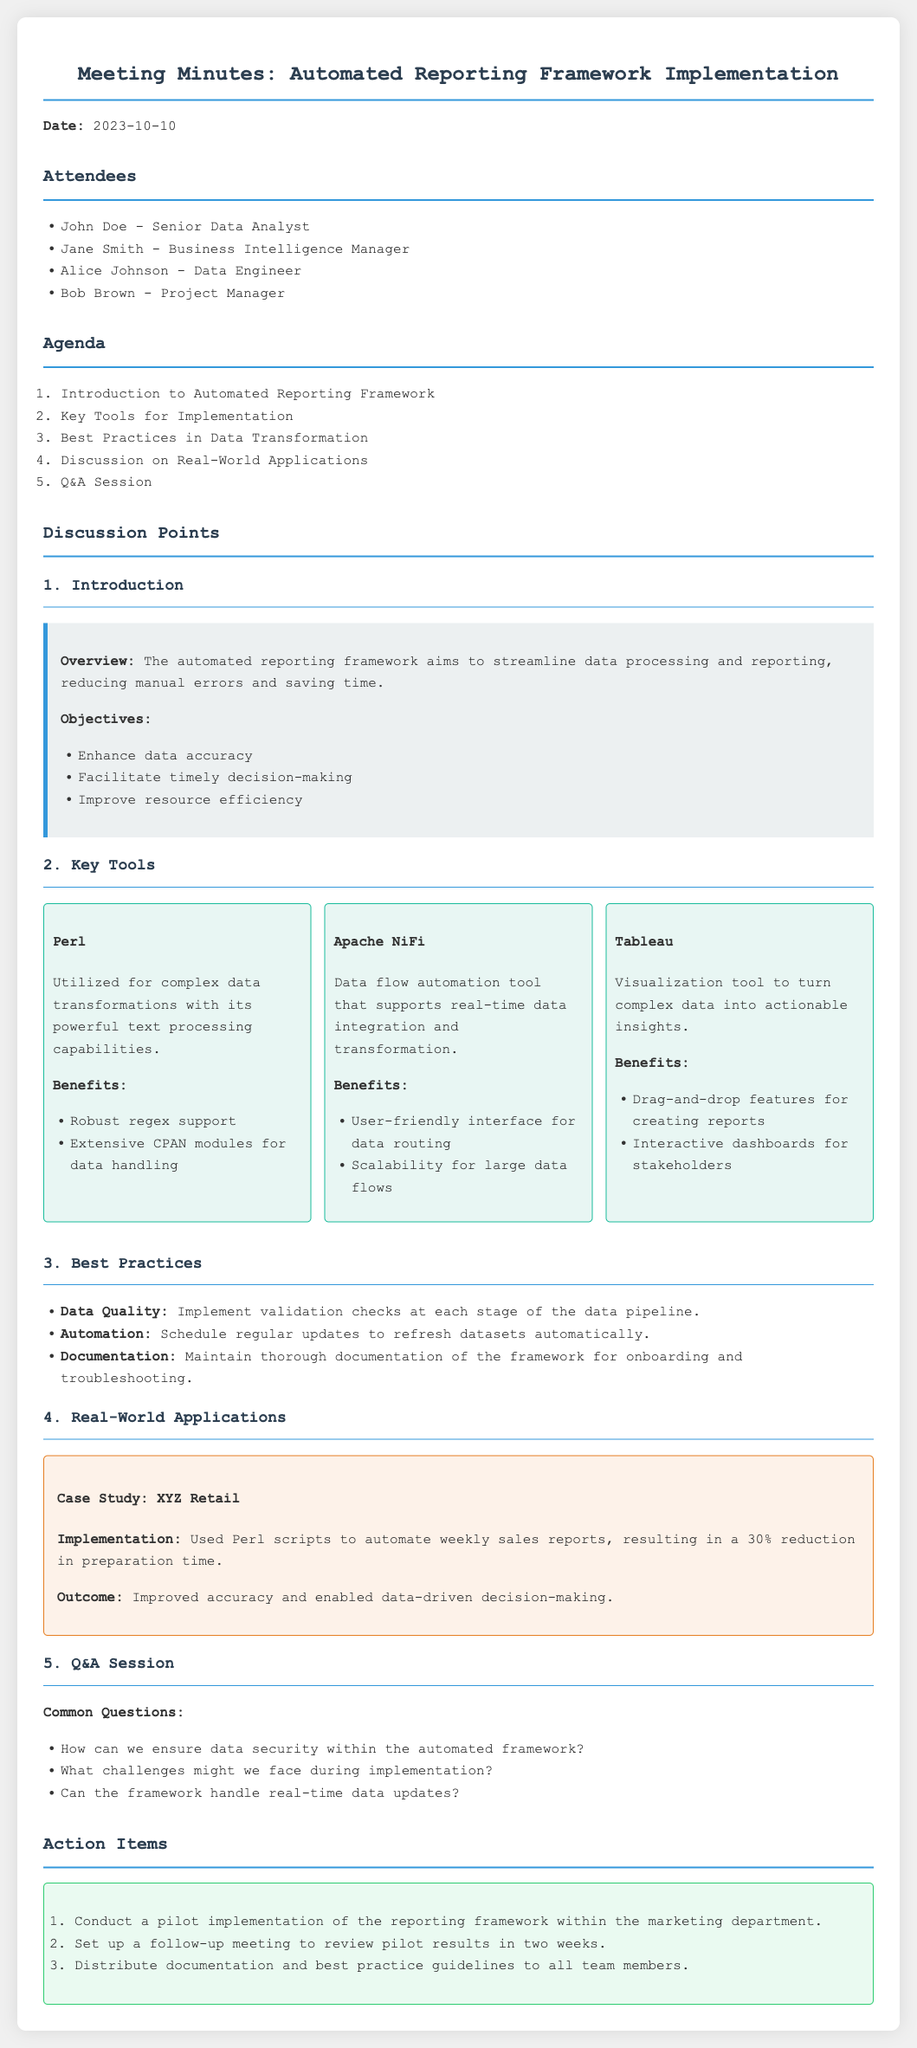What is the date of the meeting? The document states the meeting date clearly at the beginning.
Answer: 2023-10-10 Who is the Business Intelligence Manager? The list of attendees includes all participants and their roles.
Answer: Jane Smith What tool is used for complex data transformations? This tool is specifically mentioned in the section about key tools for implementation.
Answer: Perl What is one objective of the automated reporting framework? Objectives are listed in the overview section, highlighting the goals of the framework.
Answer: Enhance data accuracy What was the outcome of the case study on XYZ Retail? The case study outlines specific results and changes following implementation.
Answer: Improved accuracy and enabled data-driven decision-making How many action items are listed? The action items section enumerates the steps to be taken after the meeting.
Answer: 3 What key benefit does Apache NiFi offer? Benefits of each tool are listed clearly within their respective sections.
Answer: Scalability for large data flows What is one of the best practices mentioned? The best practices section provides guidelines that were discussed during the meeting.
Answer: Implement validation checks at each stage of the data pipeline What case study is presented in the document? The discussion includes a specific case study to illustrate real-world applications of the framework.
Answer: XYZ Retail 